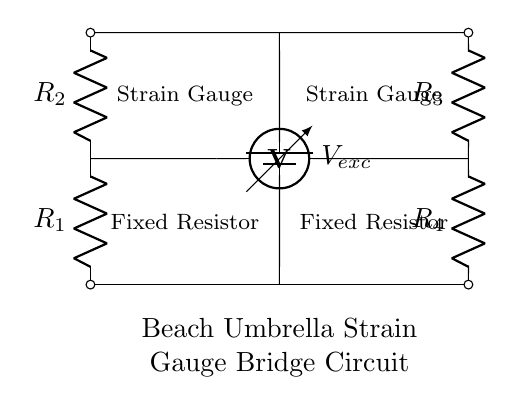What type of circuit is this? This is a bridge circuit, specifically a strain gauge bridge used for measuring changes in resistance due to applied strain. It consists of two pairs of resistors forming the bridge configuration.
Answer: Bridge circuit What components are indicated in the circuit? The components shown are two strain gauges and four resistors labeled as R1, R2, R3, and R4. The inclusion of a voltage source is also essential to the operation of the circuit.
Answer: Strain gauge, resistors What is the purpose of the strain gauges in this circuit? The strain gauges are used to detect the deformation of the beach umbrella structure caused by wind or other loads. Changes in resistance from the strain sensors help monitor structural integrity.
Answer: Monitor structural integrity What is the total number of resistors used in this circuit? The circuit contains four resistors: R1, R2, R3, and R4. These resistors are arranged to balance the bridge and measure resistance changes effectively.
Answer: Four What can be inferred if one of the resistors is removed from the circuit? Removing one of the resistors would unbalance the bridge, causing inaccurate readings from the strain gauges. This loss of balance would prevent proper measurement of structural integrity.
Answer: Inaccurate readings How is the voltage excited in this bridge circuit? The voltage is provided by a battery labeled V_ex, which supplies the necessary excitation voltage to the circuit for operation and measurement purposes.
Answer: Battery What happens to the output voltage if the strain increases? If the strain increases, the resistance of the strain gauges changes, resulting in a change in output voltage across the voltmeter connected in the bridge circuit, indicating deformation.
Answer: Output voltage changes 